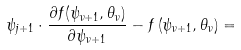Convert formula to latex. <formula><loc_0><loc_0><loc_500><loc_500>\psi _ { j + 1 } \cdot \frac { \partial f ( \psi _ { \nu + 1 } , \theta _ { \nu } ) } { \partial \psi _ { \nu + 1 } } - f \left ( \psi _ { \nu + 1 } , \theta _ { \nu } \right ) =</formula> 